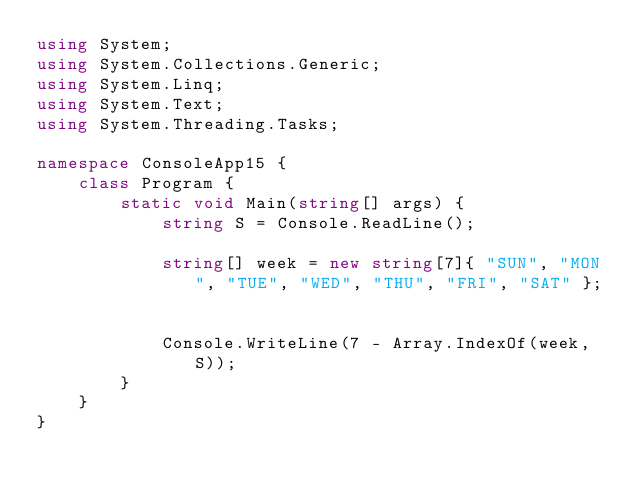<code> <loc_0><loc_0><loc_500><loc_500><_C#_>using System;
using System.Collections.Generic;
using System.Linq;
using System.Text;
using System.Threading.Tasks;

namespace ConsoleApp15 {
    class Program {
        static void Main(string[] args) {
            string S = Console.ReadLine();

            string[] week = new string[7]{ "SUN", "MON", "TUE", "WED", "THU", "FRI", "SAT" };


            Console.WriteLine(7 - Array.IndexOf(week, S));
        }
    }
}
</code> 